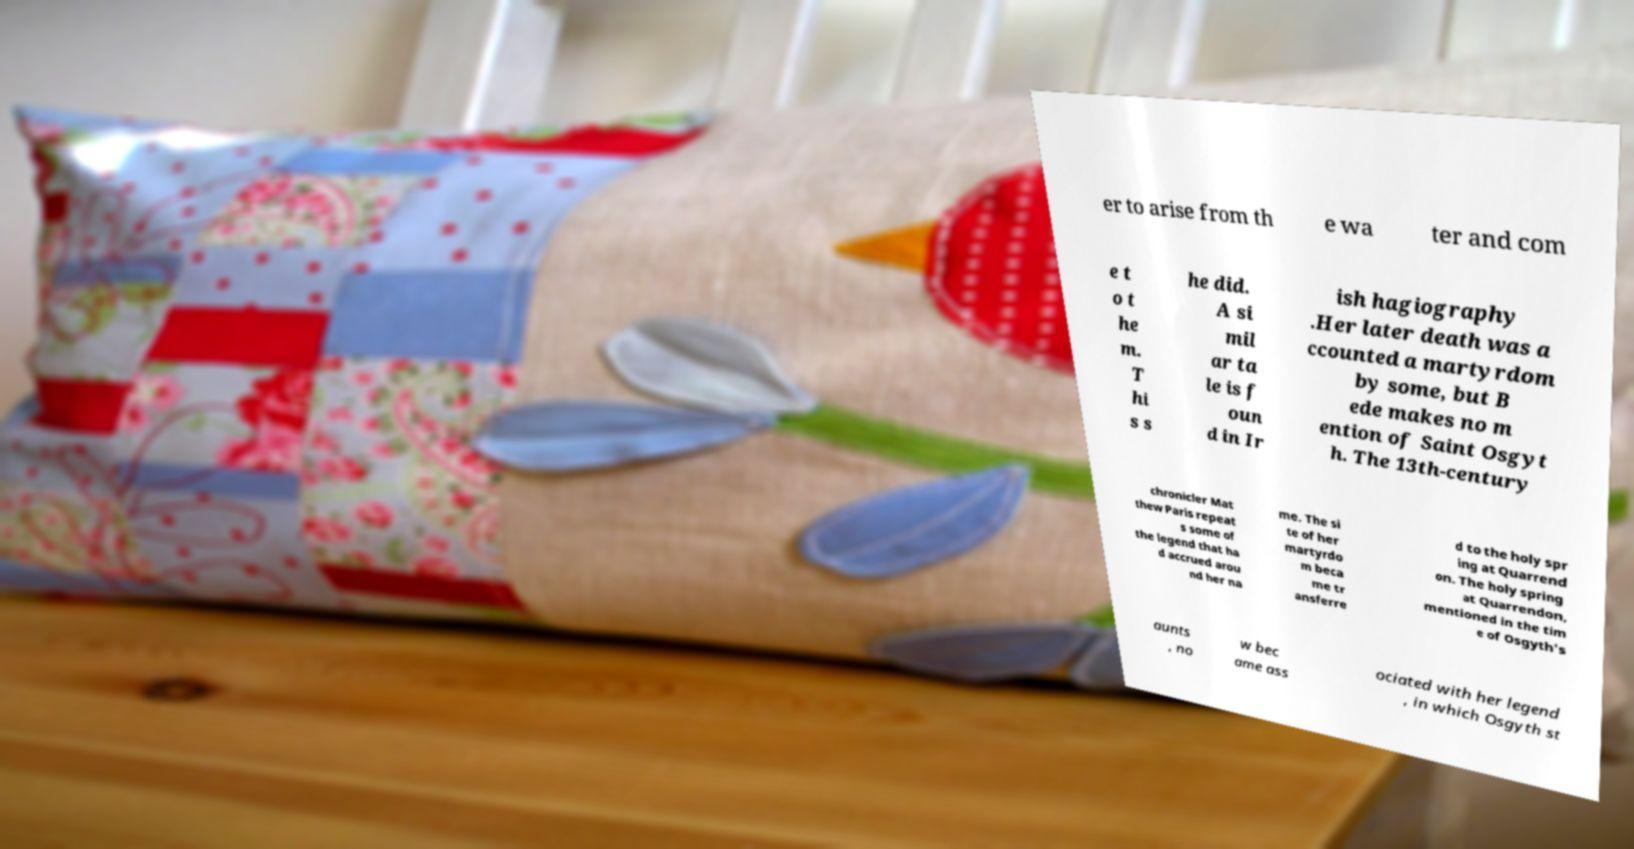Can you accurately transcribe the text from the provided image for me? er to arise from th e wa ter and com e t o t he m. T hi s s he did. A si mil ar ta le is f oun d in Ir ish hagiography .Her later death was a ccounted a martyrdom by some, but B ede makes no m ention of Saint Osgyt h. The 13th-century chronicler Mat thew Paris repeat s some of the legend that ha d accrued arou nd her na me. The si te of her martyrdo m beca me tr ansferre d to the holy spr ing at Quarrend on. The holy spring at Quarrendon, mentioned in the tim e of Osgyth's aunts , no w bec ame ass ociated with her legend , in which Osgyth st 